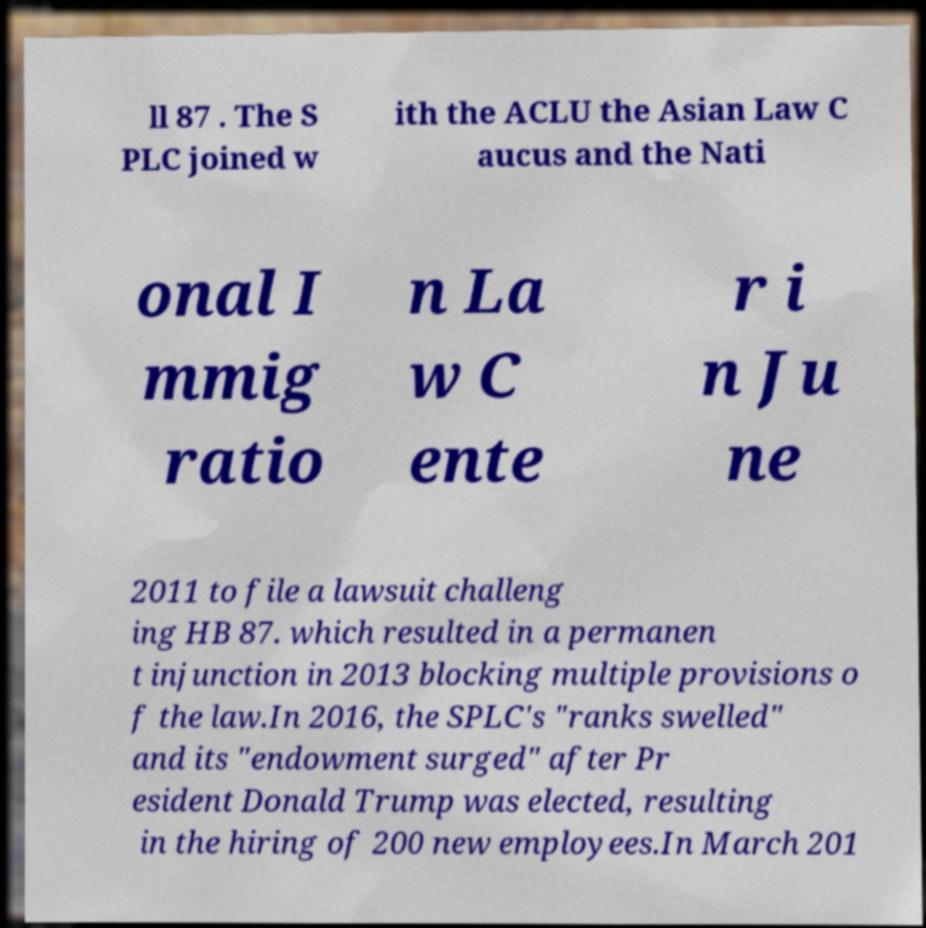There's text embedded in this image that I need extracted. Can you transcribe it verbatim? ll 87 . The S PLC joined w ith the ACLU the Asian Law C aucus and the Nati onal I mmig ratio n La w C ente r i n Ju ne 2011 to file a lawsuit challeng ing HB 87. which resulted in a permanen t injunction in 2013 blocking multiple provisions o f the law.In 2016, the SPLC's "ranks swelled" and its "endowment surged" after Pr esident Donald Trump was elected, resulting in the hiring of 200 new employees.In March 201 